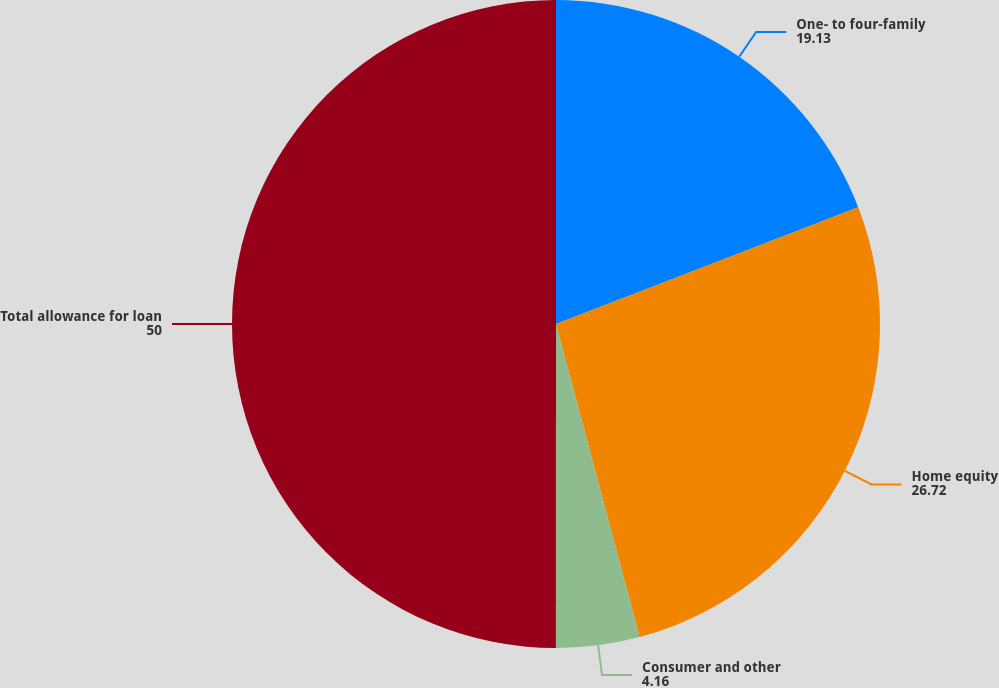<chart> <loc_0><loc_0><loc_500><loc_500><pie_chart><fcel>One- to four-family<fcel>Home equity<fcel>Consumer and other<fcel>Total allowance for loan<nl><fcel>19.13%<fcel>26.72%<fcel>4.16%<fcel>50.0%<nl></chart> 